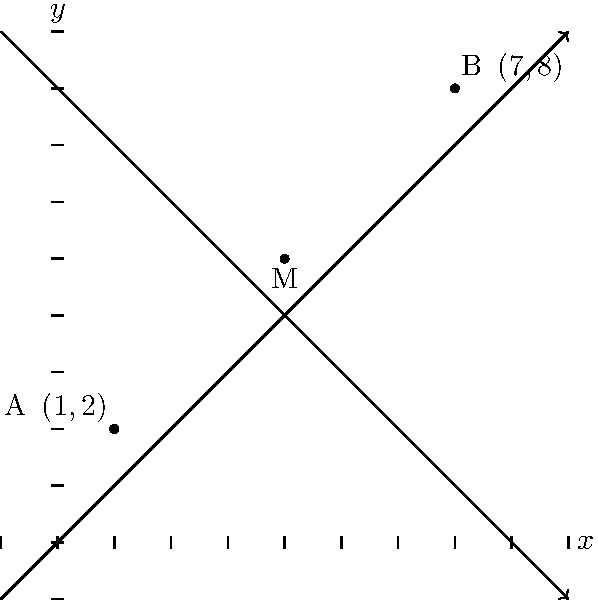During a nature hike in Hobbs State Park, you come across two trail markers on a coordinate plane. Marker A is located at $(1,2)$ and marker B is at $(7,8)$. To help plan rest stops, you need to find the coordinates of the midpoint M between these two markers. What are the coordinates of the midpoint M? To find the midpoint M between two points A$(x_1,y_1)$ and B$(x_2,y_2)$, we use the midpoint formula:

$$ M = (\frac{x_1 + x_2}{2}, \frac{y_1 + y_2}{2}) $$

Given:
- Point A: $(1,2)$
- Point B: $(7,8)$

Step 1: Calculate the x-coordinate of the midpoint:
$$ x_M = \frac{x_1 + x_2}{2} = \frac{1 + 7}{2} = \frac{8}{2} = 4 $$

Step 2: Calculate the y-coordinate of the midpoint:
$$ y_M = \frac{y_1 + y_2}{2} = \frac{2 + 8}{2} = \frac{10}{2} = 5 $$

Therefore, the coordinates of the midpoint M are $(4,5)$.
Answer: $(4,5)$ 